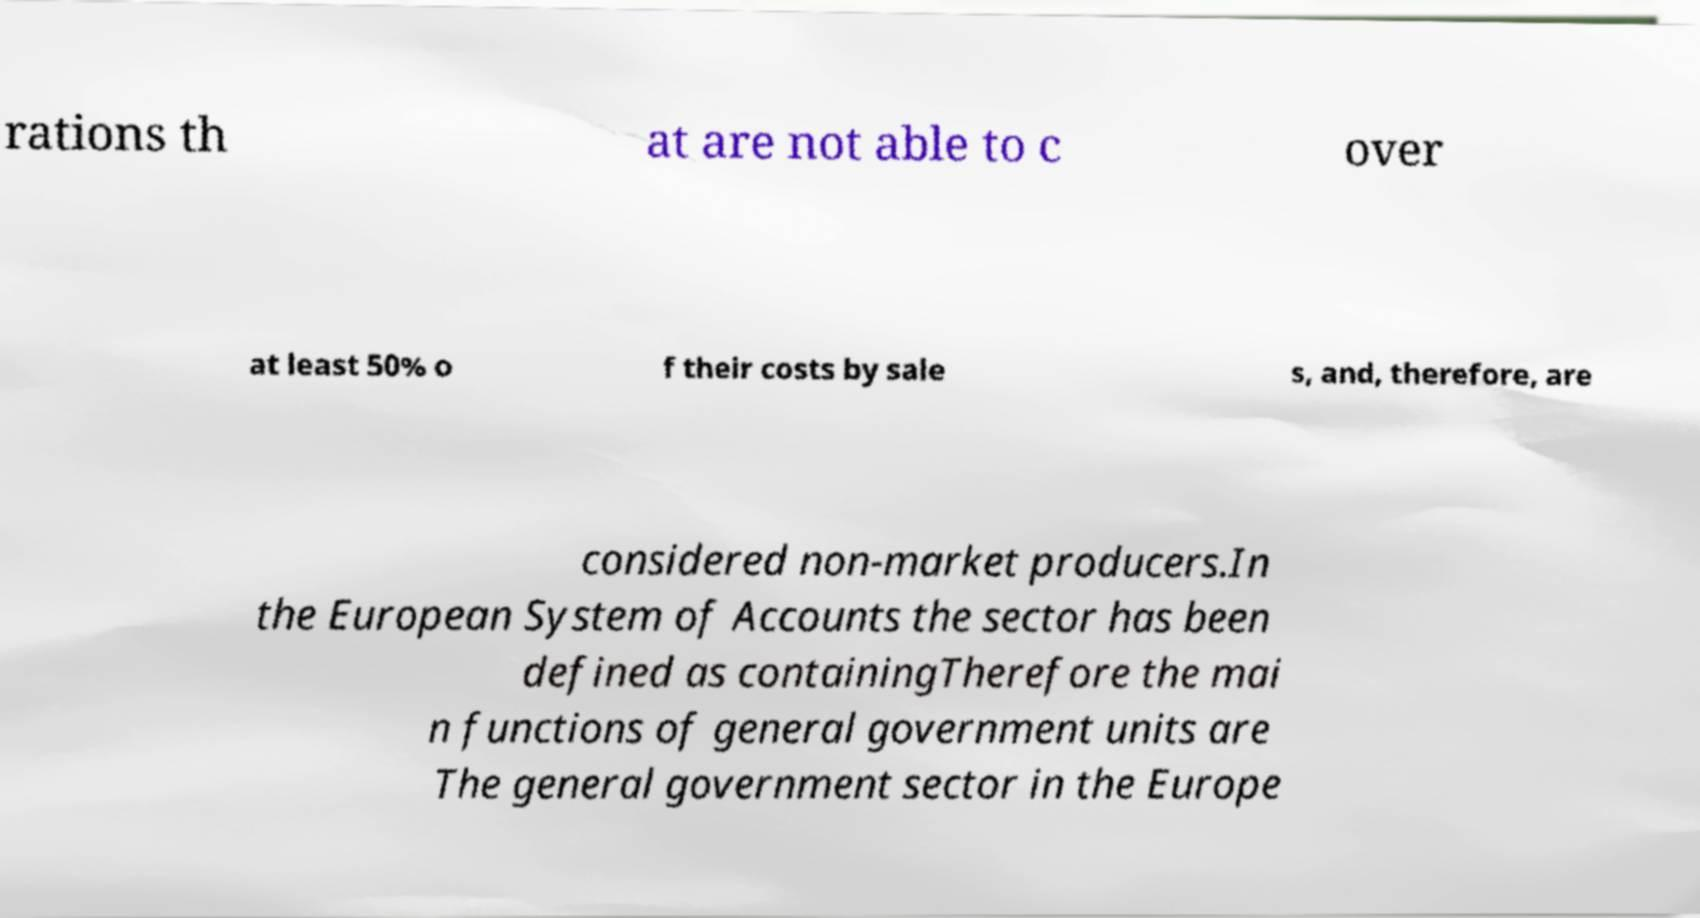I need the written content from this picture converted into text. Can you do that? rations th at are not able to c over at least 50% o f their costs by sale s, and, therefore, are considered non-market producers.In the European System of Accounts the sector has been defined as containingTherefore the mai n functions of general government units are The general government sector in the Europe 